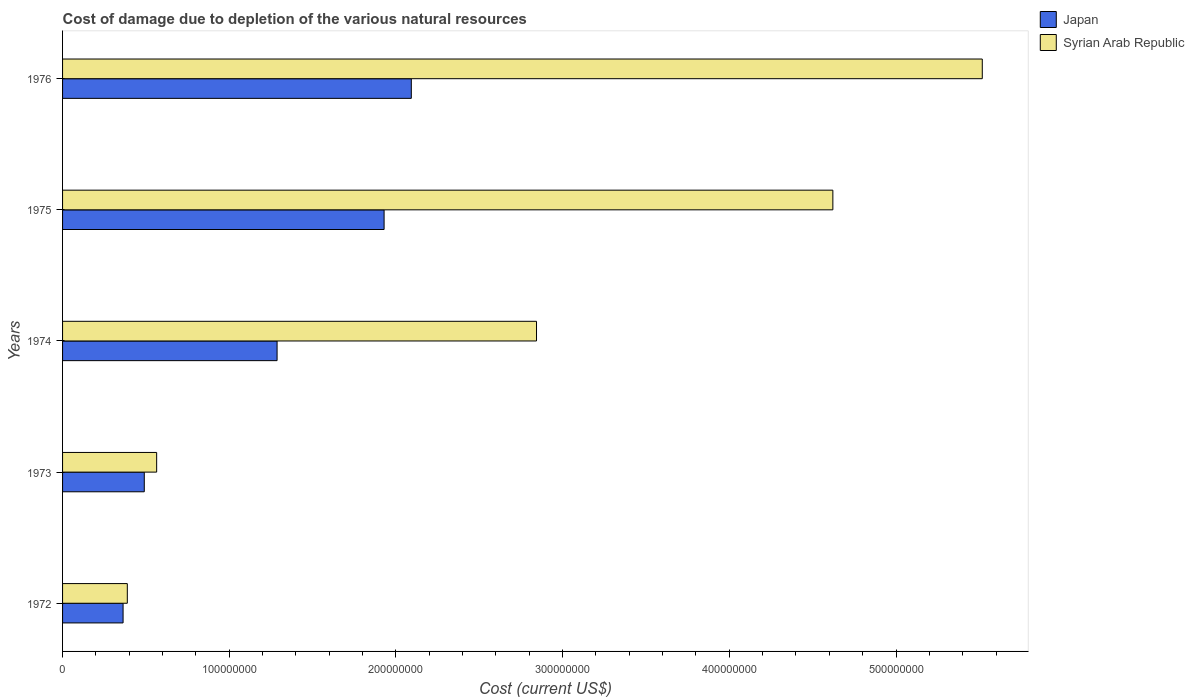How many groups of bars are there?
Your response must be concise. 5. Are the number of bars on each tick of the Y-axis equal?
Make the answer very short. Yes. How many bars are there on the 2nd tick from the top?
Ensure brevity in your answer.  2. What is the label of the 3rd group of bars from the top?
Provide a short and direct response. 1974. What is the cost of damage caused due to the depletion of various natural resources in Japan in 1973?
Provide a short and direct response. 4.90e+07. Across all years, what is the maximum cost of damage caused due to the depletion of various natural resources in Japan?
Offer a terse response. 2.09e+08. Across all years, what is the minimum cost of damage caused due to the depletion of various natural resources in Syrian Arab Republic?
Offer a terse response. 3.88e+07. In which year was the cost of damage caused due to the depletion of various natural resources in Syrian Arab Republic maximum?
Provide a succinct answer. 1976. In which year was the cost of damage caused due to the depletion of various natural resources in Japan minimum?
Provide a succinct answer. 1972. What is the total cost of damage caused due to the depletion of various natural resources in Syrian Arab Republic in the graph?
Make the answer very short. 1.39e+09. What is the difference between the cost of damage caused due to the depletion of various natural resources in Japan in 1973 and that in 1975?
Provide a succinct answer. -1.44e+08. What is the difference between the cost of damage caused due to the depletion of various natural resources in Japan in 1976 and the cost of damage caused due to the depletion of various natural resources in Syrian Arab Republic in 1974?
Make the answer very short. -7.51e+07. What is the average cost of damage caused due to the depletion of various natural resources in Syrian Arab Republic per year?
Keep it short and to the point. 2.79e+08. In the year 1973, what is the difference between the cost of damage caused due to the depletion of various natural resources in Japan and cost of damage caused due to the depletion of various natural resources in Syrian Arab Republic?
Offer a very short reply. -7.43e+06. What is the ratio of the cost of damage caused due to the depletion of various natural resources in Japan in 1972 to that in 1975?
Provide a succinct answer. 0.19. Is the cost of damage caused due to the depletion of various natural resources in Japan in 1973 less than that in 1975?
Your answer should be very brief. Yes. Is the difference between the cost of damage caused due to the depletion of various natural resources in Japan in 1973 and 1974 greater than the difference between the cost of damage caused due to the depletion of various natural resources in Syrian Arab Republic in 1973 and 1974?
Your response must be concise. Yes. What is the difference between the highest and the second highest cost of damage caused due to the depletion of various natural resources in Japan?
Ensure brevity in your answer.  1.63e+07. What is the difference between the highest and the lowest cost of damage caused due to the depletion of various natural resources in Syrian Arab Republic?
Make the answer very short. 5.13e+08. What does the 1st bar from the top in 1975 represents?
Provide a short and direct response. Syrian Arab Republic. Are all the bars in the graph horizontal?
Provide a short and direct response. Yes. What is the difference between two consecutive major ticks on the X-axis?
Offer a terse response. 1.00e+08. Are the values on the major ticks of X-axis written in scientific E-notation?
Ensure brevity in your answer.  No. Does the graph contain any zero values?
Make the answer very short. No. Does the graph contain grids?
Your answer should be compact. No. Where does the legend appear in the graph?
Your answer should be very brief. Top right. What is the title of the graph?
Make the answer very short. Cost of damage due to depletion of the various natural resources. Does "High income: nonOECD" appear as one of the legend labels in the graph?
Offer a terse response. No. What is the label or title of the X-axis?
Offer a very short reply. Cost (current US$). What is the Cost (current US$) of Japan in 1972?
Keep it short and to the point. 3.63e+07. What is the Cost (current US$) of Syrian Arab Republic in 1972?
Your answer should be compact. 3.88e+07. What is the Cost (current US$) in Japan in 1973?
Make the answer very short. 4.90e+07. What is the Cost (current US$) in Syrian Arab Republic in 1973?
Make the answer very short. 5.64e+07. What is the Cost (current US$) of Japan in 1974?
Your answer should be compact. 1.29e+08. What is the Cost (current US$) of Syrian Arab Republic in 1974?
Give a very brief answer. 2.84e+08. What is the Cost (current US$) of Japan in 1975?
Keep it short and to the point. 1.93e+08. What is the Cost (current US$) in Syrian Arab Republic in 1975?
Provide a short and direct response. 4.62e+08. What is the Cost (current US$) of Japan in 1976?
Ensure brevity in your answer.  2.09e+08. What is the Cost (current US$) of Syrian Arab Republic in 1976?
Your answer should be compact. 5.52e+08. Across all years, what is the maximum Cost (current US$) of Japan?
Make the answer very short. 2.09e+08. Across all years, what is the maximum Cost (current US$) of Syrian Arab Republic?
Your answer should be very brief. 5.52e+08. Across all years, what is the minimum Cost (current US$) of Japan?
Offer a terse response. 3.63e+07. Across all years, what is the minimum Cost (current US$) in Syrian Arab Republic?
Provide a short and direct response. 3.88e+07. What is the total Cost (current US$) in Japan in the graph?
Make the answer very short. 6.16e+08. What is the total Cost (current US$) of Syrian Arab Republic in the graph?
Your answer should be compact. 1.39e+09. What is the difference between the Cost (current US$) in Japan in 1972 and that in 1973?
Offer a very short reply. -1.27e+07. What is the difference between the Cost (current US$) in Syrian Arab Republic in 1972 and that in 1973?
Your response must be concise. -1.76e+07. What is the difference between the Cost (current US$) in Japan in 1972 and that in 1974?
Your answer should be compact. -9.24e+07. What is the difference between the Cost (current US$) of Syrian Arab Republic in 1972 and that in 1974?
Provide a succinct answer. -2.45e+08. What is the difference between the Cost (current US$) in Japan in 1972 and that in 1975?
Keep it short and to the point. -1.57e+08. What is the difference between the Cost (current US$) in Syrian Arab Republic in 1972 and that in 1975?
Your answer should be compact. -4.23e+08. What is the difference between the Cost (current US$) of Japan in 1972 and that in 1976?
Provide a succinct answer. -1.73e+08. What is the difference between the Cost (current US$) in Syrian Arab Republic in 1972 and that in 1976?
Make the answer very short. -5.13e+08. What is the difference between the Cost (current US$) of Japan in 1973 and that in 1974?
Make the answer very short. -7.97e+07. What is the difference between the Cost (current US$) of Syrian Arab Republic in 1973 and that in 1974?
Give a very brief answer. -2.28e+08. What is the difference between the Cost (current US$) of Japan in 1973 and that in 1975?
Your answer should be very brief. -1.44e+08. What is the difference between the Cost (current US$) of Syrian Arab Republic in 1973 and that in 1975?
Provide a short and direct response. -4.06e+08. What is the difference between the Cost (current US$) of Japan in 1973 and that in 1976?
Ensure brevity in your answer.  -1.60e+08. What is the difference between the Cost (current US$) of Syrian Arab Republic in 1973 and that in 1976?
Offer a very short reply. -4.95e+08. What is the difference between the Cost (current US$) in Japan in 1974 and that in 1975?
Your answer should be very brief. -6.42e+07. What is the difference between the Cost (current US$) in Syrian Arab Republic in 1974 and that in 1975?
Offer a terse response. -1.78e+08. What is the difference between the Cost (current US$) in Japan in 1974 and that in 1976?
Give a very brief answer. -8.05e+07. What is the difference between the Cost (current US$) in Syrian Arab Republic in 1974 and that in 1976?
Offer a terse response. -2.67e+08. What is the difference between the Cost (current US$) of Japan in 1975 and that in 1976?
Offer a very short reply. -1.63e+07. What is the difference between the Cost (current US$) of Syrian Arab Republic in 1975 and that in 1976?
Provide a succinct answer. -8.96e+07. What is the difference between the Cost (current US$) of Japan in 1972 and the Cost (current US$) of Syrian Arab Republic in 1973?
Offer a very short reply. -2.01e+07. What is the difference between the Cost (current US$) in Japan in 1972 and the Cost (current US$) in Syrian Arab Republic in 1974?
Give a very brief answer. -2.48e+08. What is the difference between the Cost (current US$) of Japan in 1972 and the Cost (current US$) of Syrian Arab Republic in 1975?
Offer a very short reply. -4.26e+08. What is the difference between the Cost (current US$) of Japan in 1972 and the Cost (current US$) of Syrian Arab Republic in 1976?
Ensure brevity in your answer.  -5.15e+08. What is the difference between the Cost (current US$) of Japan in 1973 and the Cost (current US$) of Syrian Arab Republic in 1974?
Your response must be concise. -2.35e+08. What is the difference between the Cost (current US$) of Japan in 1973 and the Cost (current US$) of Syrian Arab Republic in 1975?
Keep it short and to the point. -4.13e+08. What is the difference between the Cost (current US$) in Japan in 1973 and the Cost (current US$) in Syrian Arab Republic in 1976?
Your response must be concise. -5.03e+08. What is the difference between the Cost (current US$) of Japan in 1974 and the Cost (current US$) of Syrian Arab Republic in 1975?
Make the answer very short. -3.33e+08. What is the difference between the Cost (current US$) of Japan in 1974 and the Cost (current US$) of Syrian Arab Republic in 1976?
Offer a terse response. -4.23e+08. What is the difference between the Cost (current US$) in Japan in 1975 and the Cost (current US$) in Syrian Arab Republic in 1976?
Keep it short and to the point. -3.59e+08. What is the average Cost (current US$) of Japan per year?
Ensure brevity in your answer.  1.23e+08. What is the average Cost (current US$) in Syrian Arab Republic per year?
Give a very brief answer. 2.79e+08. In the year 1972, what is the difference between the Cost (current US$) of Japan and Cost (current US$) of Syrian Arab Republic?
Your response must be concise. -2.54e+06. In the year 1973, what is the difference between the Cost (current US$) in Japan and Cost (current US$) in Syrian Arab Republic?
Give a very brief answer. -7.43e+06. In the year 1974, what is the difference between the Cost (current US$) of Japan and Cost (current US$) of Syrian Arab Republic?
Give a very brief answer. -1.56e+08. In the year 1975, what is the difference between the Cost (current US$) of Japan and Cost (current US$) of Syrian Arab Republic?
Make the answer very short. -2.69e+08. In the year 1976, what is the difference between the Cost (current US$) of Japan and Cost (current US$) of Syrian Arab Republic?
Your answer should be very brief. -3.43e+08. What is the ratio of the Cost (current US$) in Japan in 1972 to that in 1973?
Ensure brevity in your answer.  0.74. What is the ratio of the Cost (current US$) in Syrian Arab Republic in 1972 to that in 1973?
Provide a succinct answer. 0.69. What is the ratio of the Cost (current US$) of Japan in 1972 to that in 1974?
Your answer should be very brief. 0.28. What is the ratio of the Cost (current US$) in Syrian Arab Republic in 1972 to that in 1974?
Provide a short and direct response. 0.14. What is the ratio of the Cost (current US$) of Japan in 1972 to that in 1975?
Provide a succinct answer. 0.19. What is the ratio of the Cost (current US$) of Syrian Arab Republic in 1972 to that in 1975?
Provide a short and direct response. 0.08. What is the ratio of the Cost (current US$) in Japan in 1972 to that in 1976?
Keep it short and to the point. 0.17. What is the ratio of the Cost (current US$) of Syrian Arab Republic in 1972 to that in 1976?
Provide a short and direct response. 0.07. What is the ratio of the Cost (current US$) of Japan in 1973 to that in 1974?
Provide a succinct answer. 0.38. What is the ratio of the Cost (current US$) of Syrian Arab Republic in 1973 to that in 1974?
Your answer should be compact. 0.2. What is the ratio of the Cost (current US$) of Japan in 1973 to that in 1975?
Ensure brevity in your answer.  0.25. What is the ratio of the Cost (current US$) in Syrian Arab Republic in 1973 to that in 1975?
Offer a very short reply. 0.12. What is the ratio of the Cost (current US$) of Japan in 1973 to that in 1976?
Give a very brief answer. 0.23. What is the ratio of the Cost (current US$) of Syrian Arab Republic in 1973 to that in 1976?
Give a very brief answer. 0.1. What is the ratio of the Cost (current US$) in Japan in 1974 to that in 1975?
Your answer should be compact. 0.67. What is the ratio of the Cost (current US$) of Syrian Arab Republic in 1974 to that in 1975?
Offer a very short reply. 0.62. What is the ratio of the Cost (current US$) in Japan in 1974 to that in 1976?
Make the answer very short. 0.62. What is the ratio of the Cost (current US$) in Syrian Arab Republic in 1974 to that in 1976?
Ensure brevity in your answer.  0.52. What is the ratio of the Cost (current US$) in Japan in 1975 to that in 1976?
Give a very brief answer. 0.92. What is the ratio of the Cost (current US$) in Syrian Arab Republic in 1975 to that in 1976?
Provide a succinct answer. 0.84. What is the difference between the highest and the second highest Cost (current US$) in Japan?
Your answer should be very brief. 1.63e+07. What is the difference between the highest and the second highest Cost (current US$) of Syrian Arab Republic?
Ensure brevity in your answer.  8.96e+07. What is the difference between the highest and the lowest Cost (current US$) in Japan?
Provide a succinct answer. 1.73e+08. What is the difference between the highest and the lowest Cost (current US$) of Syrian Arab Republic?
Ensure brevity in your answer.  5.13e+08. 